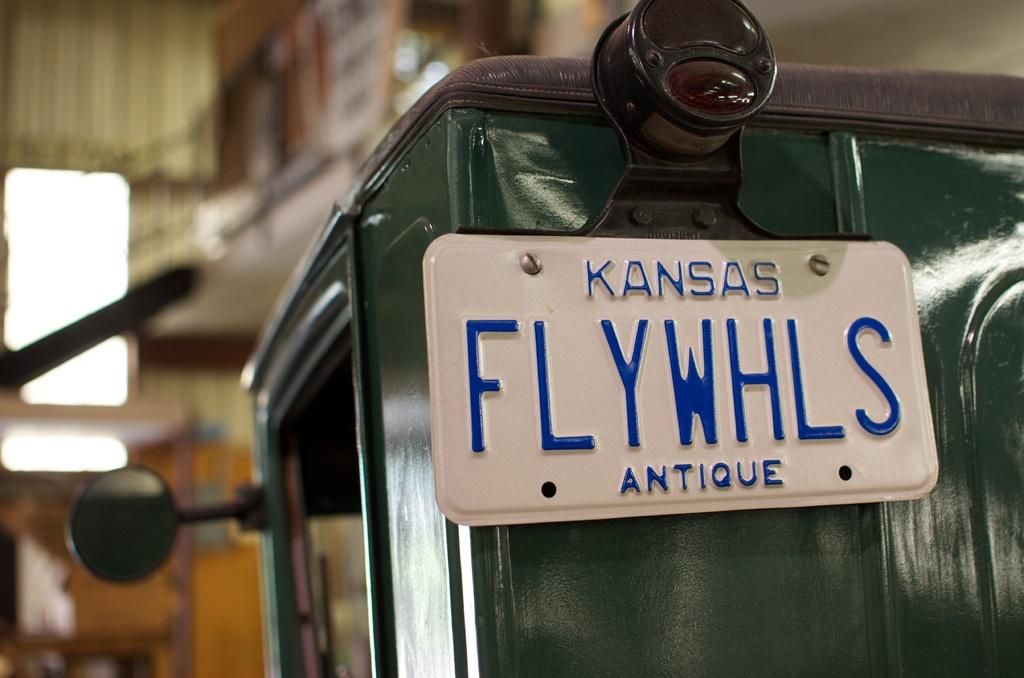What is located on the right side of the vehicle in the image? There is a board on the right side of the vehicle in the image. Can you describe the background of the image? The background of the image is blurry. Is there a squirrel taking a bath in the image? No, there is no squirrel or bath present in the image. 